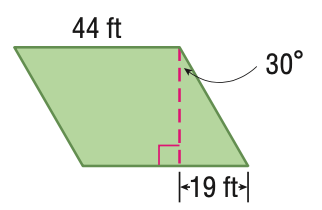Answer the mathemtical geometry problem and directly provide the correct option letter.
Question: Find the perimeter of the parallelogram. Round to the nearest tenth if necessary.
Choices: A: 82 B: 164 C: 836 D: 1448 B 